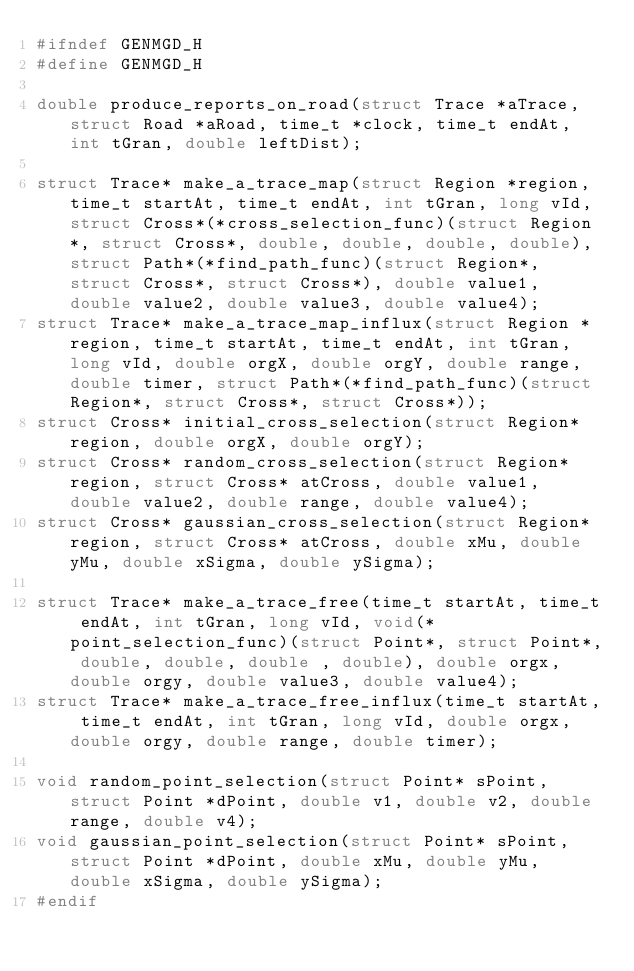Convert code to text. <code><loc_0><loc_0><loc_500><loc_500><_C_>#ifndef GENMGD_H
#define GENMGD_H

double produce_reports_on_road(struct Trace *aTrace, struct Road *aRoad, time_t *clock, time_t endAt, int tGran, double leftDist);

struct Trace* make_a_trace_map(struct Region *region, time_t startAt, time_t endAt, int tGran, long vId, struct Cross*(*cross_selection_func)(struct Region*, struct Cross*, double, double, double, double), struct Path*(*find_path_func)(struct Region*, struct Cross*, struct Cross*), double value1, double value2, double value3, double value4);
struct Trace* make_a_trace_map_influx(struct Region *region, time_t startAt, time_t endAt, int tGran, long vId, double orgX, double orgY, double range, double timer, struct Path*(*find_path_func)(struct Region*, struct Cross*, struct Cross*));
struct Cross* initial_cross_selection(struct Region* region, double orgX, double orgY);
struct Cross* random_cross_selection(struct Region* region, struct Cross* atCross, double value1, double value2, double range, double value4);
struct Cross* gaussian_cross_selection(struct Region* region, struct Cross* atCross, double xMu, double yMu, double xSigma, double ySigma);

struct Trace* make_a_trace_free(time_t startAt, time_t endAt, int tGran, long vId, void(*point_selection_func)(struct Point*, struct Point*, double, double, double , double), double orgx, double orgy, double value3, double value4);
struct Trace* make_a_trace_free_influx(time_t startAt, time_t endAt, int tGran, long vId, double orgx, double orgy, double range, double timer);

void random_point_selection(struct Point* sPoint, struct Point *dPoint, double v1, double v2, double range, double v4);
void gaussian_point_selection(struct Point* sPoint, struct Point *dPoint, double xMu, double yMu, double xSigma, double ySigma);
#endif
</code> 